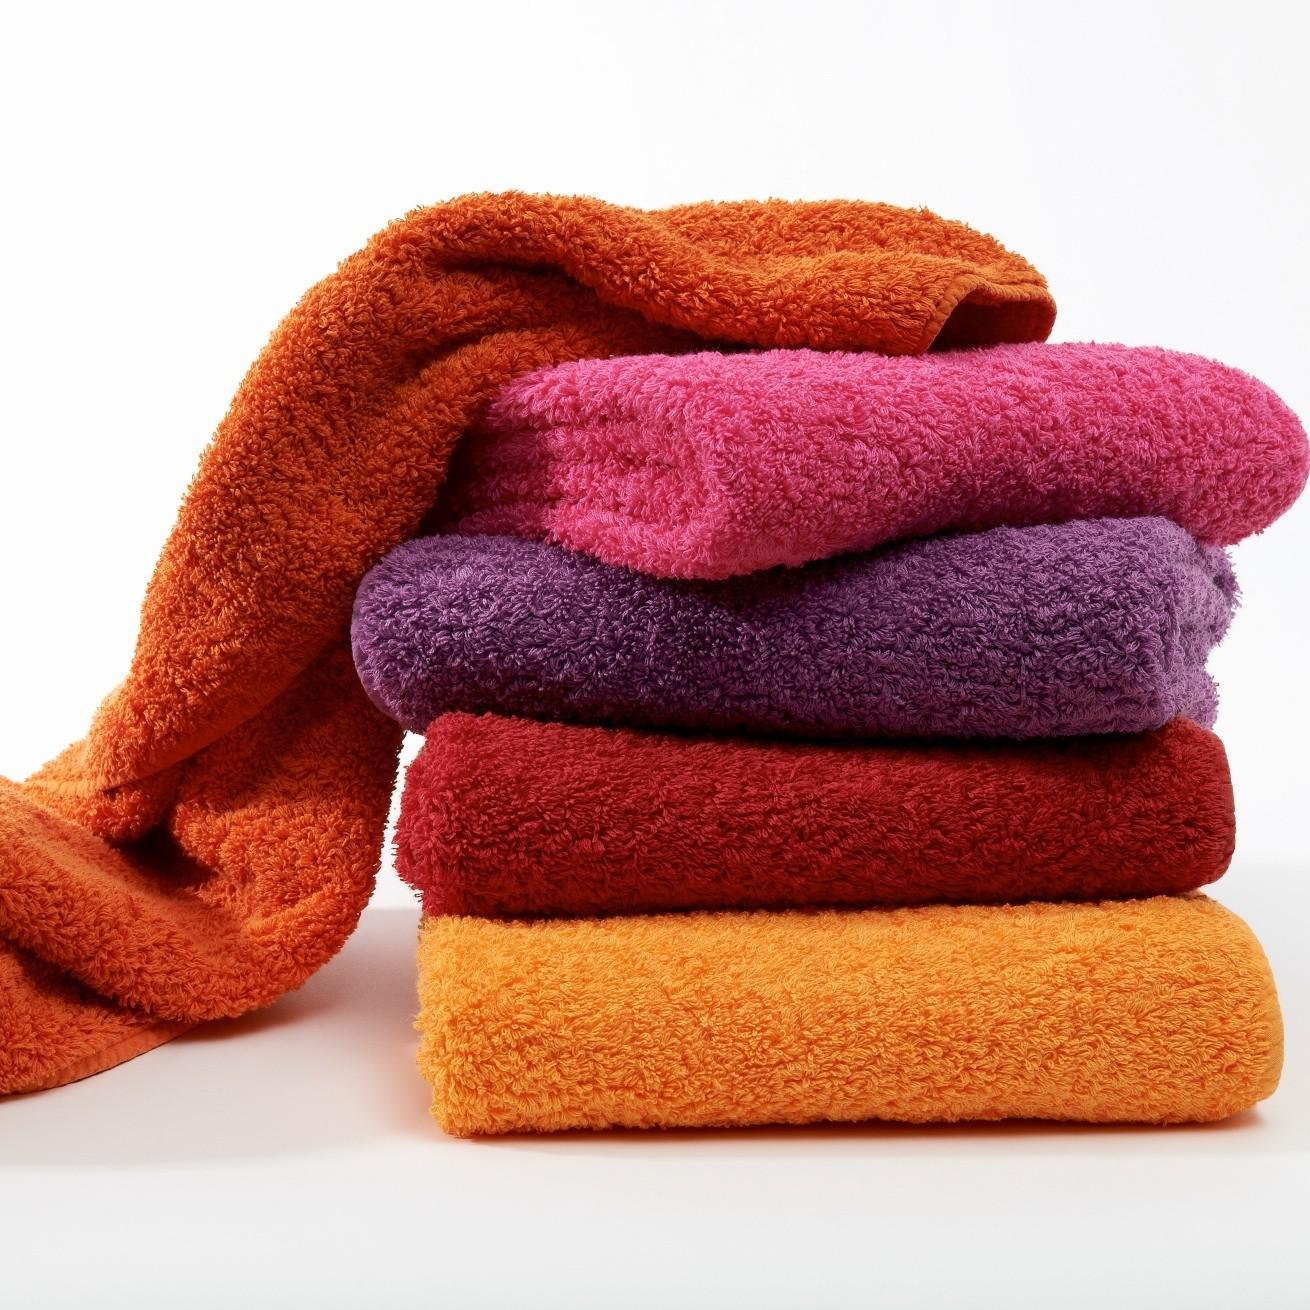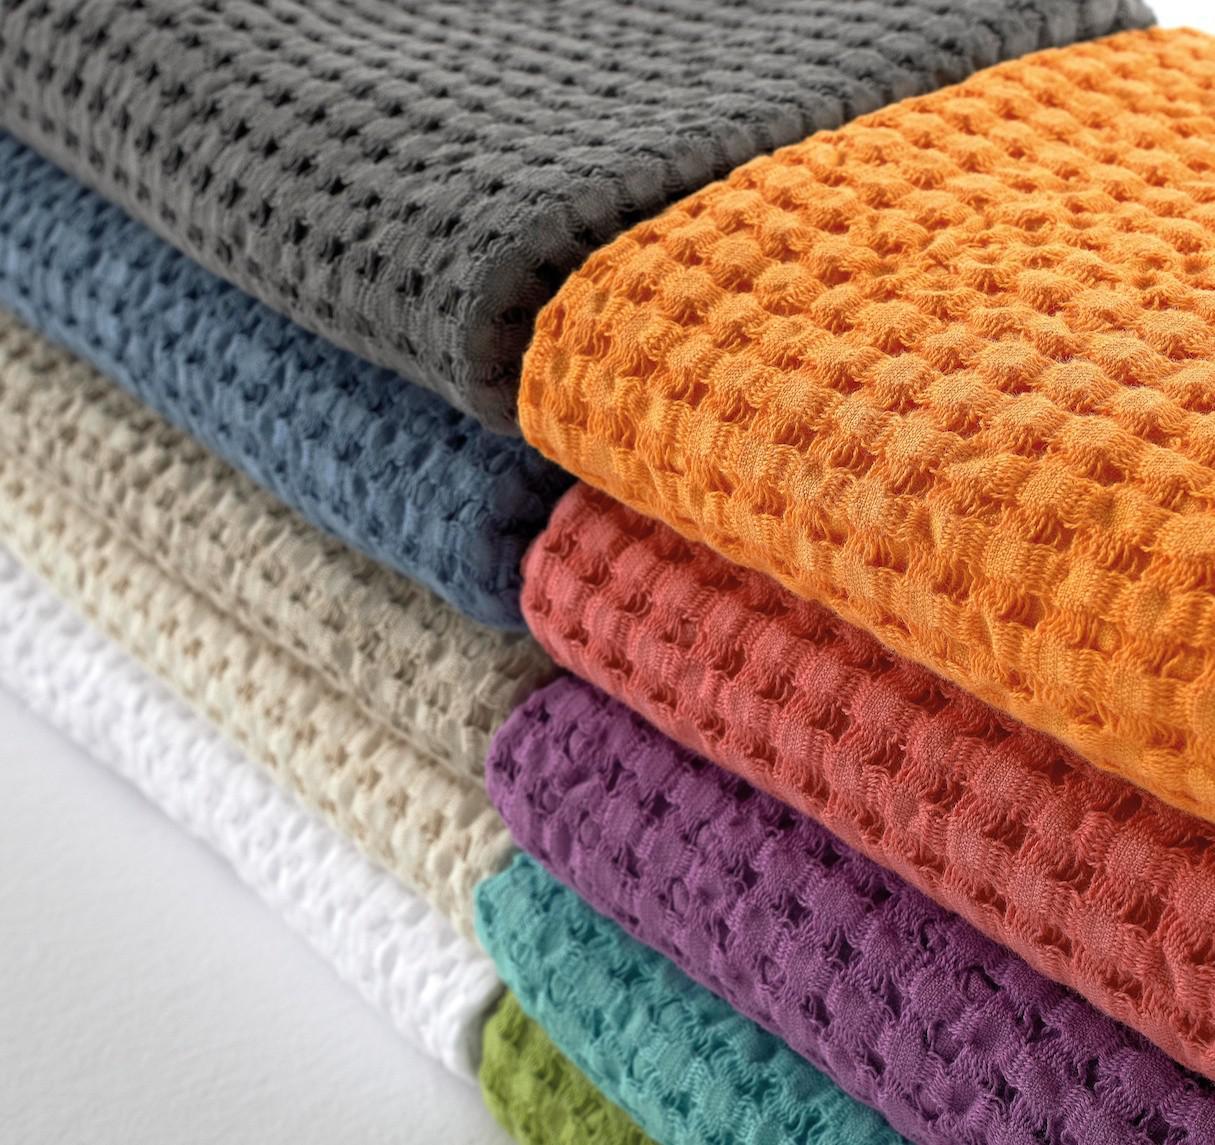The first image is the image on the left, the second image is the image on the right. Evaluate the accuracy of this statement regarding the images: "There is a least two towers of four towels.". Is it true? Answer yes or no. Yes. The first image is the image on the left, the second image is the image on the right. Examine the images to the left and right. Is the description "There is at least one stack of regularly folded towels in each image, with at least 3 different colors of towel per image." accurate? Answer yes or no. Yes. 